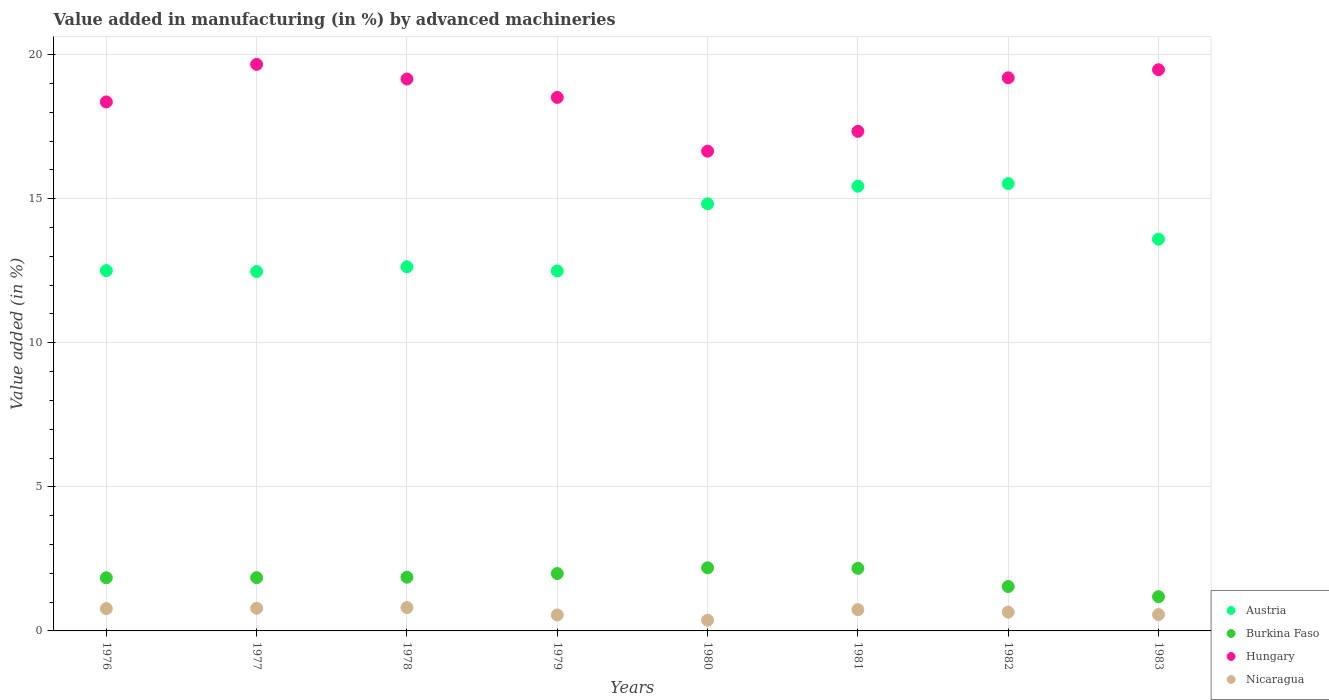How many different coloured dotlines are there?
Offer a very short reply. 4. What is the percentage of value added in manufacturing by advanced machineries in Burkina Faso in 1982?
Make the answer very short. 1.54. Across all years, what is the maximum percentage of value added in manufacturing by advanced machineries in Nicaragua?
Your response must be concise. 0.81. Across all years, what is the minimum percentage of value added in manufacturing by advanced machineries in Austria?
Your response must be concise. 12.47. What is the total percentage of value added in manufacturing by advanced machineries in Austria in the graph?
Ensure brevity in your answer.  109.49. What is the difference between the percentage of value added in manufacturing by advanced machineries in Hungary in 1976 and that in 1979?
Your answer should be compact. -0.16. What is the difference between the percentage of value added in manufacturing by advanced machineries in Nicaragua in 1980 and the percentage of value added in manufacturing by advanced machineries in Austria in 1982?
Keep it short and to the point. -15.16. What is the average percentage of value added in manufacturing by advanced machineries in Hungary per year?
Offer a very short reply. 18.54. In the year 1980, what is the difference between the percentage of value added in manufacturing by advanced machineries in Austria and percentage of value added in manufacturing by advanced machineries in Nicaragua?
Give a very brief answer. 14.45. In how many years, is the percentage of value added in manufacturing by advanced machineries in Austria greater than 4 %?
Offer a terse response. 8. What is the ratio of the percentage of value added in manufacturing by advanced machineries in Austria in 1979 to that in 1982?
Ensure brevity in your answer.  0.8. Is the difference between the percentage of value added in manufacturing by advanced machineries in Austria in 1977 and 1979 greater than the difference between the percentage of value added in manufacturing by advanced machineries in Nicaragua in 1977 and 1979?
Your answer should be very brief. No. What is the difference between the highest and the second highest percentage of value added in manufacturing by advanced machineries in Hungary?
Your response must be concise. 0.19. What is the difference between the highest and the lowest percentage of value added in manufacturing by advanced machineries in Austria?
Offer a very short reply. 3.05. Is the sum of the percentage of value added in manufacturing by advanced machineries in Hungary in 1982 and 1983 greater than the maximum percentage of value added in manufacturing by advanced machineries in Burkina Faso across all years?
Your answer should be very brief. Yes. Does the percentage of value added in manufacturing by advanced machineries in Burkina Faso monotonically increase over the years?
Ensure brevity in your answer.  No. Is the percentage of value added in manufacturing by advanced machineries in Austria strictly greater than the percentage of value added in manufacturing by advanced machineries in Nicaragua over the years?
Your response must be concise. Yes. Is the percentage of value added in manufacturing by advanced machineries in Burkina Faso strictly less than the percentage of value added in manufacturing by advanced machineries in Hungary over the years?
Provide a succinct answer. Yes. What is the difference between two consecutive major ticks on the Y-axis?
Offer a very short reply. 5. Does the graph contain any zero values?
Ensure brevity in your answer.  No. How many legend labels are there?
Your response must be concise. 4. What is the title of the graph?
Make the answer very short. Value added in manufacturing (in %) by advanced machineries. Does "Bermuda" appear as one of the legend labels in the graph?
Offer a very short reply. No. What is the label or title of the Y-axis?
Offer a terse response. Value added (in %). What is the Value added (in %) of Austria in 1976?
Your answer should be compact. 12.5. What is the Value added (in %) of Burkina Faso in 1976?
Offer a very short reply. 1.85. What is the Value added (in %) of Hungary in 1976?
Ensure brevity in your answer.  18.36. What is the Value added (in %) of Nicaragua in 1976?
Your response must be concise. 0.77. What is the Value added (in %) in Austria in 1977?
Provide a succinct answer. 12.47. What is the Value added (in %) in Burkina Faso in 1977?
Give a very brief answer. 1.85. What is the Value added (in %) in Hungary in 1977?
Provide a succinct answer. 19.66. What is the Value added (in %) in Nicaragua in 1977?
Provide a succinct answer. 0.79. What is the Value added (in %) of Austria in 1978?
Your answer should be compact. 12.64. What is the Value added (in %) of Burkina Faso in 1978?
Give a very brief answer. 1.86. What is the Value added (in %) in Hungary in 1978?
Your response must be concise. 19.16. What is the Value added (in %) in Nicaragua in 1978?
Give a very brief answer. 0.81. What is the Value added (in %) of Austria in 1979?
Your answer should be very brief. 12.49. What is the Value added (in %) of Burkina Faso in 1979?
Your response must be concise. 1.99. What is the Value added (in %) of Hungary in 1979?
Offer a very short reply. 18.52. What is the Value added (in %) of Nicaragua in 1979?
Ensure brevity in your answer.  0.55. What is the Value added (in %) of Austria in 1980?
Your response must be concise. 14.82. What is the Value added (in %) in Burkina Faso in 1980?
Ensure brevity in your answer.  2.19. What is the Value added (in %) of Hungary in 1980?
Keep it short and to the point. 16.65. What is the Value added (in %) in Nicaragua in 1980?
Your answer should be compact. 0.37. What is the Value added (in %) of Austria in 1981?
Offer a terse response. 15.43. What is the Value added (in %) in Burkina Faso in 1981?
Your answer should be compact. 2.17. What is the Value added (in %) in Hungary in 1981?
Your response must be concise. 17.34. What is the Value added (in %) of Nicaragua in 1981?
Your answer should be very brief. 0.74. What is the Value added (in %) in Austria in 1982?
Give a very brief answer. 15.53. What is the Value added (in %) in Burkina Faso in 1982?
Keep it short and to the point. 1.54. What is the Value added (in %) in Hungary in 1982?
Provide a short and direct response. 19.2. What is the Value added (in %) of Nicaragua in 1982?
Your response must be concise. 0.65. What is the Value added (in %) in Austria in 1983?
Your response must be concise. 13.6. What is the Value added (in %) in Burkina Faso in 1983?
Keep it short and to the point. 1.19. What is the Value added (in %) in Hungary in 1983?
Give a very brief answer. 19.48. What is the Value added (in %) in Nicaragua in 1983?
Your answer should be very brief. 0.57. Across all years, what is the maximum Value added (in %) in Austria?
Provide a succinct answer. 15.53. Across all years, what is the maximum Value added (in %) in Burkina Faso?
Provide a short and direct response. 2.19. Across all years, what is the maximum Value added (in %) of Hungary?
Ensure brevity in your answer.  19.66. Across all years, what is the maximum Value added (in %) in Nicaragua?
Make the answer very short. 0.81. Across all years, what is the minimum Value added (in %) of Austria?
Make the answer very short. 12.47. Across all years, what is the minimum Value added (in %) in Burkina Faso?
Offer a terse response. 1.19. Across all years, what is the minimum Value added (in %) of Hungary?
Provide a succinct answer. 16.65. Across all years, what is the minimum Value added (in %) of Nicaragua?
Your response must be concise. 0.37. What is the total Value added (in %) of Austria in the graph?
Keep it short and to the point. 109.49. What is the total Value added (in %) of Burkina Faso in the graph?
Offer a terse response. 14.64. What is the total Value added (in %) of Hungary in the graph?
Make the answer very short. 148.36. What is the total Value added (in %) in Nicaragua in the graph?
Keep it short and to the point. 5.26. What is the difference between the Value added (in %) of Austria in 1976 and that in 1977?
Ensure brevity in your answer.  0.03. What is the difference between the Value added (in %) in Burkina Faso in 1976 and that in 1977?
Ensure brevity in your answer.  -0. What is the difference between the Value added (in %) of Hungary in 1976 and that in 1977?
Your answer should be compact. -1.3. What is the difference between the Value added (in %) of Nicaragua in 1976 and that in 1977?
Give a very brief answer. -0.01. What is the difference between the Value added (in %) in Austria in 1976 and that in 1978?
Provide a short and direct response. -0.13. What is the difference between the Value added (in %) in Burkina Faso in 1976 and that in 1978?
Offer a terse response. -0.02. What is the difference between the Value added (in %) of Hungary in 1976 and that in 1978?
Provide a succinct answer. -0.8. What is the difference between the Value added (in %) of Nicaragua in 1976 and that in 1978?
Offer a very short reply. -0.04. What is the difference between the Value added (in %) of Austria in 1976 and that in 1979?
Ensure brevity in your answer.  0.01. What is the difference between the Value added (in %) in Burkina Faso in 1976 and that in 1979?
Keep it short and to the point. -0.15. What is the difference between the Value added (in %) in Hungary in 1976 and that in 1979?
Your answer should be very brief. -0.16. What is the difference between the Value added (in %) of Nicaragua in 1976 and that in 1979?
Keep it short and to the point. 0.22. What is the difference between the Value added (in %) of Austria in 1976 and that in 1980?
Your answer should be compact. -2.32. What is the difference between the Value added (in %) of Burkina Faso in 1976 and that in 1980?
Offer a terse response. -0.35. What is the difference between the Value added (in %) in Hungary in 1976 and that in 1980?
Provide a succinct answer. 1.71. What is the difference between the Value added (in %) of Nicaragua in 1976 and that in 1980?
Offer a terse response. 0.4. What is the difference between the Value added (in %) of Austria in 1976 and that in 1981?
Offer a terse response. -2.93. What is the difference between the Value added (in %) of Burkina Faso in 1976 and that in 1981?
Offer a very short reply. -0.33. What is the difference between the Value added (in %) in Hungary in 1976 and that in 1981?
Your answer should be compact. 1.02. What is the difference between the Value added (in %) in Nicaragua in 1976 and that in 1981?
Your answer should be compact. 0.04. What is the difference between the Value added (in %) in Austria in 1976 and that in 1982?
Your response must be concise. -3.02. What is the difference between the Value added (in %) of Burkina Faso in 1976 and that in 1982?
Provide a short and direct response. 0.3. What is the difference between the Value added (in %) in Hungary in 1976 and that in 1982?
Your answer should be very brief. -0.84. What is the difference between the Value added (in %) in Nicaragua in 1976 and that in 1982?
Provide a short and direct response. 0.12. What is the difference between the Value added (in %) in Austria in 1976 and that in 1983?
Keep it short and to the point. -1.09. What is the difference between the Value added (in %) in Burkina Faso in 1976 and that in 1983?
Give a very brief answer. 0.66. What is the difference between the Value added (in %) in Hungary in 1976 and that in 1983?
Your response must be concise. -1.12. What is the difference between the Value added (in %) of Nicaragua in 1976 and that in 1983?
Offer a very short reply. 0.21. What is the difference between the Value added (in %) of Austria in 1977 and that in 1978?
Offer a very short reply. -0.16. What is the difference between the Value added (in %) in Burkina Faso in 1977 and that in 1978?
Your answer should be very brief. -0.02. What is the difference between the Value added (in %) in Hungary in 1977 and that in 1978?
Your response must be concise. 0.51. What is the difference between the Value added (in %) of Nicaragua in 1977 and that in 1978?
Your answer should be very brief. -0.02. What is the difference between the Value added (in %) in Austria in 1977 and that in 1979?
Give a very brief answer. -0.02. What is the difference between the Value added (in %) in Burkina Faso in 1977 and that in 1979?
Offer a terse response. -0.14. What is the difference between the Value added (in %) in Hungary in 1977 and that in 1979?
Provide a succinct answer. 1.15. What is the difference between the Value added (in %) of Nicaragua in 1977 and that in 1979?
Provide a succinct answer. 0.23. What is the difference between the Value added (in %) of Austria in 1977 and that in 1980?
Ensure brevity in your answer.  -2.35. What is the difference between the Value added (in %) of Burkina Faso in 1977 and that in 1980?
Give a very brief answer. -0.34. What is the difference between the Value added (in %) in Hungary in 1977 and that in 1980?
Provide a succinct answer. 3.01. What is the difference between the Value added (in %) of Nicaragua in 1977 and that in 1980?
Offer a terse response. 0.42. What is the difference between the Value added (in %) in Austria in 1977 and that in 1981?
Offer a very short reply. -2.96. What is the difference between the Value added (in %) in Burkina Faso in 1977 and that in 1981?
Give a very brief answer. -0.32. What is the difference between the Value added (in %) of Hungary in 1977 and that in 1981?
Make the answer very short. 2.32. What is the difference between the Value added (in %) of Nicaragua in 1977 and that in 1981?
Your response must be concise. 0.05. What is the difference between the Value added (in %) in Austria in 1977 and that in 1982?
Give a very brief answer. -3.05. What is the difference between the Value added (in %) of Burkina Faso in 1977 and that in 1982?
Provide a short and direct response. 0.31. What is the difference between the Value added (in %) in Hungary in 1977 and that in 1982?
Your response must be concise. 0.47. What is the difference between the Value added (in %) of Nicaragua in 1977 and that in 1982?
Ensure brevity in your answer.  0.13. What is the difference between the Value added (in %) in Austria in 1977 and that in 1983?
Offer a very short reply. -1.12. What is the difference between the Value added (in %) in Burkina Faso in 1977 and that in 1983?
Give a very brief answer. 0.66. What is the difference between the Value added (in %) of Hungary in 1977 and that in 1983?
Keep it short and to the point. 0.19. What is the difference between the Value added (in %) in Nicaragua in 1977 and that in 1983?
Make the answer very short. 0.22. What is the difference between the Value added (in %) in Austria in 1978 and that in 1979?
Your answer should be very brief. 0.14. What is the difference between the Value added (in %) in Burkina Faso in 1978 and that in 1979?
Your answer should be compact. -0.13. What is the difference between the Value added (in %) in Hungary in 1978 and that in 1979?
Your answer should be very brief. 0.64. What is the difference between the Value added (in %) of Nicaragua in 1978 and that in 1979?
Provide a short and direct response. 0.25. What is the difference between the Value added (in %) in Austria in 1978 and that in 1980?
Provide a succinct answer. -2.19. What is the difference between the Value added (in %) in Burkina Faso in 1978 and that in 1980?
Your answer should be very brief. -0.33. What is the difference between the Value added (in %) in Hungary in 1978 and that in 1980?
Give a very brief answer. 2.5. What is the difference between the Value added (in %) of Nicaragua in 1978 and that in 1980?
Your answer should be very brief. 0.44. What is the difference between the Value added (in %) of Austria in 1978 and that in 1981?
Your response must be concise. -2.8. What is the difference between the Value added (in %) of Burkina Faso in 1978 and that in 1981?
Make the answer very short. -0.31. What is the difference between the Value added (in %) in Hungary in 1978 and that in 1981?
Give a very brief answer. 1.82. What is the difference between the Value added (in %) of Nicaragua in 1978 and that in 1981?
Offer a terse response. 0.07. What is the difference between the Value added (in %) of Austria in 1978 and that in 1982?
Your answer should be very brief. -2.89. What is the difference between the Value added (in %) of Burkina Faso in 1978 and that in 1982?
Make the answer very short. 0.32. What is the difference between the Value added (in %) in Hungary in 1978 and that in 1982?
Your answer should be compact. -0.04. What is the difference between the Value added (in %) of Nicaragua in 1978 and that in 1982?
Offer a terse response. 0.16. What is the difference between the Value added (in %) of Austria in 1978 and that in 1983?
Offer a very short reply. -0.96. What is the difference between the Value added (in %) in Burkina Faso in 1978 and that in 1983?
Ensure brevity in your answer.  0.68. What is the difference between the Value added (in %) in Hungary in 1978 and that in 1983?
Your response must be concise. -0.32. What is the difference between the Value added (in %) in Nicaragua in 1978 and that in 1983?
Your response must be concise. 0.24. What is the difference between the Value added (in %) in Austria in 1979 and that in 1980?
Your answer should be compact. -2.33. What is the difference between the Value added (in %) in Burkina Faso in 1979 and that in 1980?
Provide a short and direct response. -0.2. What is the difference between the Value added (in %) in Hungary in 1979 and that in 1980?
Provide a succinct answer. 1.86. What is the difference between the Value added (in %) of Nicaragua in 1979 and that in 1980?
Your answer should be very brief. 0.18. What is the difference between the Value added (in %) of Austria in 1979 and that in 1981?
Keep it short and to the point. -2.94. What is the difference between the Value added (in %) in Burkina Faso in 1979 and that in 1981?
Provide a succinct answer. -0.18. What is the difference between the Value added (in %) of Hungary in 1979 and that in 1981?
Make the answer very short. 1.18. What is the difference between the Value added (in %) of Nicaragua in 1979 and that in 1981?
Your answer should be very brief. -0.18. What is the difference between the Value added (in %) in Austria in 1979 and that in 1982?
Provide a succinct answer. -3.03. What is the difference between the Value added (in %) in Burkina Faso in 1979 and that in 1982?
Give a very brief answer. 0.45. What is the difference between the Value added (in %) in Hungary in 1979 and that in 1982?
Give a very brief answer. -0.68. What is the difference between the Value added (in %) of Nicaragua in 1979 and that in 1982?
Your response must be concise. -0.1. What is the difference between the Value added (in %) in Austria in 1979 and that in 1983?
Make the answer very short. -1.1. What is the difference between the Value added (in %) in Burkina Faso in 1979 and that in 1983?
Offer a very short reply. 0.8. What is the difference between the Value added (in %) of Hungary in 1979 and that in 1983?
Keep it short and to the point. -0.96. What is the difference between the Value added (in %) of Nicaragua in 1979 and that in 1983?
Give a very brief answer. -0.01. What is the difference between the Value added (in %) of Austria in 1980 and that in 1981?
Make the answer very short. -0.61. What is the difference between the Value added (in %) in Burkina Faso in 1980 and that in 1981?
Your answer should be very brief. 0.02. What is the difference between the Value added (in %) of Hungary in 1980 and that in 1981?
Ensure brevity in your answer.  -0.69. What is the difference between the Value added (in %) in Nicaragua in 1980 and that in 1981?
Your response must be concise. -0.37. What is the difference between the Value added (in %) of Austria in 1980 and that in 1982?
Provide a succinct answer. -0.7. What is the difference between the Value added (in %) in Burkina Faso in 1980 and that in 1982?
Make the answer very short. 0.65. What is the difference between the Value added (in %) of Hungary in 1980 and that in 1982?
Your response must be concise. -2.55. What is the difference between the Value added (in %) in Nicaragua in 1980 and that in 1982?
Give a very brief answer. -0.28. What is the difference between the Value added (in %) of Austria in 1980 and that in 1983?
Your answer should be very brief. 1.23. What is the difference between the Value added (in %) of Hungary in 1980 and that in 1983?
Your answer should be very brief. -2.83. What is the difference between the Value added (in %) in Nicaragua in 1980 and that in 1983?
Provide a succinct answer. -0.2. What is the difference between the Value added (in %) of Austria in 1981 and that in 1982?
Your answer should be very brief. -0.09. What is the difference between the Value added (in %) in Burkina Faso in 1981 and that in 1982?
Your answer should be compact. 0.63. What is the difference between the Value added (in %) of Hungary in 1981 and that in 1982?
Make the answer very short. -1.86. What is the difference between the Value added (in %) in Nicaragua in 1981 and that in 1982?
Keep it short and to the point. 0.09. What is the difference between the Value added (in %) in Austria in 1981 and that in 1983?
Provide a succinct answer. 1.84. What is the difference between the Value added (in %) of Burkina Faso in 1981 and that in 1983?
Give a very brief answer. 0.98. What is the difference between the Value added (in %) in Hungary in 1981 and that in 1983?
Offer a terse response. -2.14. What is the difference between the Value added (in %) of Nicaragua in 1981 and that in 1983?
Offer a terse response. 0.17. What is the difference between the Value added (in %) of Austria in 1982 and that in 1983?
Offer a terse response. 1.93. What is the difference between the Value added (in %) in Burkina Faso in 1982 and that in 1983?
Give a very brief answer. 0.35. What is the difference between the Value added (in %) of Hungary in 1982 and that in 1983?
Keep it short and to the point. -0.28. What is the difference between the Value added (in %) in Nicaragua in 1982 and that in 1983?
Offer a terse response. 0.08. What is the difference between the Value added (in %) of Austria in 1976 and the Value added (in %) of Burkina Faso in 1977?
Your response must be concise. 10.66. What is the difference between the Value added (in %) in Austria in 1976 and the Value added (in %) in Hungary in 1977?
Offer a very short reply. -7.16. What is the difference between the Value added (in %) in Austria in 1976 and the Value added (in %) in Nicaragua in 1977?
Offer a terse response. 11.72. What is the difference between the Value added (in %) in Burkina Faso in 1976 and the Value added (in %) in Hungary in 1977?
Offer a terse response. -17.82. What is the difference between the Value added (in %) of Burkina Faso in 1976 and the Value added (in %) of Nicaragua in 1977?
Offer a very short reply. 1.06. What is the difference between the Value added (in %) of Hungary in 1976 and the Value added (in %) of Nicaragua in 1977?
Your response must be concise. 17.57. What is the difference between the Value added (in %) in Austria in 1976 and the Value added (in %) in Burkina Faso in 1978?
Provide a succinct answer. 10.64. What is the difference between the Value added (in %) of Austria in 1976 and the Value added (in %) of Hungary in 1978?
Provide a succinct answer. -6.65. What is the difference between the Value added (in %) in Austria in 1976 and the Value added (in %) in Nicaragua in 1978?
Your answer should be very brief. 11.69. What is the difference between the Value added (in %) of Burkina Faso in 1976 and the Value added (in %) of Hungary in 1978?
Offer a terse response. -17.31. What is the difference between the Value added (in %) of Burkina Faso in 1976 and the Value added (in %) of Nicaragua in 1978?
Give a very brief answer. 1.04. What is the difference between the Value added (in %) in Hungary in 1976 and the Value added (in %) in Nicaragua in 1978?
Give a very brief answer. 17.55. What is the difference between the Value added (in %) of Austria in 1976 and the Value added (in %) of Burkina Faso in 1979?
Keep it short and to the point. 10.51. What is the difference between the Value added (in %) in Austria in 1976 and the Value added (in %) in Hungary in 1979?
Ensure brevity in your answer.  -6.01. What is the difference between the Value added (in %) of Austria in 1976 and the Value added (in %) of Nicaragua in 1979?
Your answer should be very brief. 11.95. What is the difference between the Value added (in %) in Burkina Faso in 1976 and the Value added (in %) in Hungary in 1979?
Keep it short and to the point. -16.67. What is the difference between the Value added (in %) of Burkina Faso in 1976 and the Value added (in %) of Nicaragua in 1979?
Your answer should be very brief. 1.29. What is the difference between the Value added (in %) in Hungary in 1976 and the Value added (in %) in Nicaragua in 1979?
Keep it short and to the point. 17.81. What is the difference between the Value added (in %) in Austria in 1976 and the Value added (in %) in Burkina Faso in 1980?
Ensure brevity in your answer.  10.31. What is the difference between the Value added (in %) in Austria in 1976 and the Value added (in %) in Hungary in 1980?
Make the answer very short. -4.15. What is the difference between the Value added (in %) in Austria in 1976 and the Value added (in %) in Nicaragua in 1980?
Make the answer very short. 12.13. What is the difference between the Value added (in %) of Burkina Faso in 1976 and the Value added (in %) of Hungary in 1980?
Provide a short and direct response. -14.81. What is the difference between the Value added (in %) in Burkina Faso in 1976 and the Value added (in %) in Nicaragua in 1980?
Keep it short and to the point. 1.47. What is the difference between the Value added (in %) in Hungary in 1976 and the Value added (in %) in Nicaragua in 1980?
Provide a short and direct response. 17.99. What is the difference between the Value added (in %) of Austria in 1976 and the Value added (in %) of Burkina Faso in 1981?
Make the answer very short. 10.33. What is the difference between the Value added (in %) in Austria in 1976 and the Value added (in %) in Hungary in 1981?
Your answer should be compact. -4.83. What is the difference between the Value added (in %) of Austria in 1976 and the Value added (in %) of Nicaragua in 1981?
Give a very brief answer. 11.76. What is the difference between the Value added (in %) in Burkina Faso in 1976 and the Value added (in %) in Hungary in 1981?
Offer a very short reply. -15.49. What is the difference between the Value added (in %) of Burkina Faso in 1976 and the Value added (in %) of Nicaragua in 1981?
Your answer should be very brief. 1.11. What is the difference between the Value added (in %) in Hungary in 1976 and the Value added (in %) in Nicaragua in 1981?
Ensure brevity in your answer.  17.62. What is the difference between the Value added (in %) of Austria in 1976 and the Value added (in %) of Burkina Faso in 1982?
Your answer should be very brief. 10.96. What is the difference between the Value added (in %) in Austria in 1976 and the Value added (in %) in Hungary in 1982?
Offer a terse response. -6.69. What is the difference between the Value added (in %) in Austria in 1976 and the Value added (in %) in Nicaragua in 1982?
Your response must be concise. 11.85. What is the difference between the Value added (in %) of Burkina Faso in 1976 and the Value added (in %) of Hungary in 1982?
Your response must be concise. -17.35. What is the difference between the Value added (in %) in Burkina Faso in 1976 and the Value added (in %) in Nicaragua in 1982?
Your answer should be compact. 1.19. What is the difference between the Value added (in %) of Hungary in 1976 and the Value added (in %) of Nicaragua in 1982?
Offer a very short reply. 17.71. What is the difference between the Value added (in %) in Austria in 1976 and the Value added (in %) in Burkina Faso in 1983?
Ensure brevity in your answer.  11.32. What is the difference between the Value added (in %) of Austria in 1976 and the Value added (in %) of Hungary in 1983?
Your response must be concise. -6.97. What is the difference between the Value added (in %) in Austria in 1976 and the Value added (in %) in Nicaragua in 1983?
Give a very brief answer. 11.94. What is the difference between the Value added (in %) in Burkina Faso in 1976 and the Value added (in %) in Hungary in 1983?
Offer a terse response. -17.63. What is the difference between the Value added (in %) in Burkina Faso in 1976 and the Value added (in %) in Nicaragua in 1983?
Ensure brevity in your answer.  1.28. What is the difference between the Value added (in %) of Hungary in 1976 and the Value added (in %) of Nicaragua in 1983?
Your response must be concise. 17.79. What is the difference between the Value added (in %) in Austria in 1977 and the Value added (in %) in Burkina Faso in 1978?
Offer a very short reply. 10.61. What is the difference between the Value added (in %) in Austria in 1977 and the Value added (in %) in Hungary in 1978?
Make the answer very short. -6.68. What is the difference between the Value added (in %) of Austria in 1977 and the Value added (in %) of Nicaragua in 1978?
Provide a succinct answer. 11.66. What is the difference between the Value added (in %) of Burkina Faso in 1977 and the Value added (in %) of Hungary in 1978?
Your response must be concise. -17.31. What is the difference between the Value added (in %) in Burkina Faso in 1977 and the Value added (in %) in Nicaragua in 1978?
Give a very brief answer. 1.04. What is the difference between the Value added (in %) in Hungary in 1977 and the Value added (in %) in Nicaragua in 1978?
Your response must be concise. 18.85. What is the difference between the Value added (in %) of Austria in 1977 and the Value added (in %) of Burkina Faso in 1979?
Offer a terse response. 10.48. What is the difference between the Value added (in %) in Austria in 1977 and the Value added (in %) in Hungary in 1979?
Your answer should be very brief. -6.04. What is the difference between the Value added (in %) of Austria in 1977 and the Value added (in %) of Nicaragua in 1979?
Your answer should be compact. 11.92. What is the difference between the Value added (in %) of Burkina Faso in 1977 and the Value added (in %) of Hungary in 1979?
Offer a terse response. -16.67. What is the difference between the Value added (in %) in Burkina Faso in 1977 and the Value added (in %) in Nicaragua in 1979?
Make the answer very short. 1.29. What is the difference between the Value added (in %) of Hungary in 1977 and the Value added (in %) of Nicaragua in 1979?
Your answer should be very brief. 19.11. What is the difference between the Value added (in %) in Austria in 1977 and the Value added (in %) in Burkina Faso in 1980?
Offer a terse response. 10.28. What is the difference between the Value added (in %) in Austria in 1977 and the Value added (in %) in Hungary in 1980?
Your response must be concise. -4.18. What is the difference between the Value added (in %) of Austria in 1977 and the Value added (in %) of Nicaragua in 1980?
Offer a very short reply. 12.1. What is the difference between the Value added (in %) of Burkina Faso in 1977 and the Value added (in %) of Hungary in 1980?
Your answer should be compact. -14.8. What is the difference between the Value added (in %) of Burkina Faso in 1977 and the Value added (in %) of Nicaragua in 1980?
Provide a short and direct response. 1.48. What is the difference between the Value added (in %) in Hungary in 1977 and the Value added (in %) in Nicaragua in 1980?
Offer a terse response. 19.29. What is the difference between the Value added (in %) of Austria in 1977 and the Value added (in %) of Burkina Faso in 1981?
Give a very brief answer. 10.3. What is the difference between the Value added (in %) of Austria in 1977 and the Value added (in %) of Hungary in 1981?
Your answer should be compact. -4.86. What is the difference between the Value added (in %) of Austria in 1977 and the Value added (in %) of Nicaragua in 1981?
Give a very brief answer. 11.73. What is the difference between the Value added (in %) of Burkina Faso in 1977 and the Value added (in %) of Hungary in 1981?
Your response must be concise. -15.49. What is the difference between the Value added (in %) in Burkina Faso in 1977 and the Value added (in %) in Nicaragua in 1981?
Provide a succinct answer. 1.11. What is the difference between the Value added (in %) of Hungary in 1977 and the Value added (in %) of Nicaragua in 1981?
Make the answer very short. 18.92. What is the difference between the Value added (in %) of Austria in 1977 and the Value added (in %) of Burkina Faso in 1982?
Make the answer very short. 10.93. What is the difference between the Value added (in %) in Austria in 1977 and the Value added (in %) in Hungary in 1982?
Your answer should be compact. -6.72. What is the difference between the Value added (in %) of Austria in 1977 and the Value added (in %) of Nicaragua in 1982?
Offer a terse response. 11.82. What is the difference between the Value added (in %) in Burkina Faso in 1977 and the Value added (in %) in Hungary in 1982?
Your response must be concise. -17.35. What is the difference between the Value added (in %) in Burkina Faso in 1977 and the Value added (in %) in Nicaragua in 1982?
Provide a succinct answer. 1.2. What is the difference between the Value added (in %) of Hungary in 1977 and the Value added (in %) of Nicaragua in 1982?
Your answer should be very brief. 19.01. What is the difference between the Value added (in %) of Austria in 1977 and the Value added (in %) of Burkina Faso in 1983?
Provide a succinct answer. 11.29. What is the difference between the Value added (in %) in Austria in 1977 and the Value added (in %) in Hungary in 1983?
Your response must be concise. -7. What is the difference between the Value added (in %) of Austria in 1977 and the Value added (in %) of Nicaragua in 1983?
Your answer should be very brief. 11.91. What is the difference between the Value added (in %) in Burkina Faso in 1977 and the Value added (in %) in Hungary in 1983?
Your answer should be compact. -17.63. What is the difference between the Value added (in %) in Burkina Faso in 1977 and the Value added (in %) in Nicaragua in 1983?
Offer a terse response. 1.28. What is the difference between the Value added (in %) of Hungary in 1977 and the Value added (in %) of Nicaragua in 1983?
Make the answer very short. 19.1. What is the difference between the Value added (in %) in Austria in 1978 and the Value added (in %) in Burkina Faso in 1979?
Provide a succinct answer. 10.65. What is the difference between the Value added (in %) of Austria in 1978 and the Value added (in %) of Hungary in 1979?
Give a very brief answer. -5.88. What is the difference between the Value added (in %) of Austria in 1978 and the Value added (in %) of Nicaragua in 1979?
Make the answer very short. 12.08. What is the difference between the Value added (in %) in Burkina Faso in 1978 and the Value added (in %) in Hungary in 1979?
Your answer should be compact. -16.65. What is the difference between the Value added (in %) in Burkina Faso in 1978 and the Value added (in %) in Nicaragua in 1979?
Give a very brief answer. 1.31. What is the difference between the Value added (in %) of Hungary in 1978 and the Value added (in %) of Nicaragua in 1979?
Provide a short and direct response. 18.6. What is the difference between the Value added (in %) in Austria in 1978 and the Value added (in %) in Burkina Faso in 1980?
Offer a terse response. 10.45. What is the difference between the Value added (in %) of Austria in 1978 and the Value added (in %) of Hungary in 1980?
Provide a succinct answer. -4.01. What is the difference between the Value added (in %) of Austria in 1978 and the Value added (in %) of Nicaragua in 1980?
Give a very brief answer. 12.27. What is the difference between the Value added (in %) of Burkina Faso in 1978 and the Value added (in %) of Hungary in 1980?
Provide a succinct answer. -14.79. What is the difference between the Value added (in %) in Burkina Faso in 1978 and the Value added (in %) in Nicaragua in 1980?
Offer a terse response. 1.49. What is the difference between the Value added (in %) in Hungary in 1978 and the Value added (in %) in Nicaragua in 1980?
Offer a very short reply. 18.78. What is the difference between the Value added (in %) in Austria in 1978 and the Value added (in %) in Burkina Faso in 1981?
Your answer should be very brief. 10.46. What is the difference between the Value added (in %) of Austria in 1978 and the Value added (in %) of Hungary in 1981?
Your answer should be very brief. -4.7. What is the difference between the Value added (in %) in Austria in 1978 and the Value added (in %) in Nicaragua in 1981?
Offer a very short reply. 11.9. What is the difference between the Value added (in %) in Burkina Faso in 1978 and the Value added (in %) in Hungary in 1981?
Your answer should be very brief. -15.48. What is the difference between the Value added (in %) of Burkina Faso in 1978 and the Value added (in %) of Nicaragua in 1981?
Keep it short and to the point. 1.12. What is the difference between the Value added (in %) of Hungary in 1978 and the Value added (in %) of Nicaragua in 1981?
Keep it short and to the point. 18.42. What is the difference between the Value added (in %) of Austria in 1978 and the Value added (in %) of Burkina Faso in 1982?
Provide a succinct answer. 11.1. What is the difference between the Value added (in %) in Austria in 1978 and the Value added (in %) in Hungary in 1982?
Offer a very short reply. -6.56. What is the difference between the Value added (in %) in Austria in 1978 and the Value added (in %) in Nicaragua in 1982?
Provide a succinct answer. 11.98. What is the difference between the Value added (in %) of Burkina Faso in 1978 and the Value added (in %) of Hungary in 1982?
Keep it short and to the point. -17.33. What is the difference between the Value added (in %) of Burkina Faso in 1978 and the Value added (in %) of Nicaragua in 1982?
Your response must be concise. 1.21. What is the difference between the Value added (in %) in Hungary in 1978 and the Value added (in %) in Nicaragua in 1982?
Give a very brief answer. 18.5. What is the difference between the Value added (in %) of Austria in 1978 and the Value added (in %) of Burkina Faso in 1983?
Offer a very short reply. 11.45. What is the difference between the Value added (in %) in Austria in 1978 and the Value added (in %) in Hungary in 1983?
Offer a terse response. -6.84. What is the difference between the Value added (in %) of Austria in 1978 and the Value added (in %) of Nicaragua in 1983?
Offer a terse response. 12.07. What is the difference between the Value added (in %) in Burkina Faso in 1978 and the Value added (in %) in Hungary in 1983?
Your answer should be very brief. -17.61. What is the difference between the Value added (in %) of Burkina Faso in 1978 and the Value added (in %) of Nicaragua in 1983?
Keep it short and to the point. 1.3. What is the difference between the Value added (in %) in Hungary in 1978 and the Value added (in %) in Nicaragua in 1983?
Keep it short and to the point. 18.59. What is the difference between the Value added (in %) of Austria in 1979 and the Value added (in %) of Burkina Faso in 1980?
Your answer should be very brief. 10.3. What is the difference between the Value added (in %) in Austria in 1979 and the Value added (in %) in Hungary in 1980?
Your answer should be very brief. -4.16. What is the difference between the Value added (in %) in Austria in 1979 and the Value added (in %) in Nicaragua in 1980?
Give a very brief answer. 12.12. What is the difference between the Value added (in %) in Burkina Faso in 1979 and the Value added (in %) in Hungary in 1980?
Provide a short and direct response. -14.66. What is the difference between the Value added (in %) of Burkina Faso in 1979 and the Value added (in %) of Nicaragua in 1980?
Keep it short and to the point. 1.62. What is the difference between the Value added (in %) in Hungary in 1979 and the Value added (in %) in Nicaragua in 1980?
Provide a short and direct response. 18.15. What is the difference between the Value added (in %) in Austria in 1979 and the Value added (in %) in Burkina Faso in 1981?
Ensure brevity in your answer.  10.32. What is the difference between the Value added (in %) of Austria in 1979 and the Value added (in %) of Hungary in 1981?
Your answer should be very brief. -4.85. What is the difference between the Value added (in %) of Austria in 1979 and the Value added (in %) of Nicaragua in 1981?
Your answer should be very brief. 11.75. What is the difference between the Value added (in %) of Burkina Faso in 1979 and the Value added (in %) of Hungary in 1981?
Your answer should be compact. -15.35. What is the difference between the Value added (in %) of Burkina Faso in 1979 and the Value added (in %) of Nicaragua in 1981?
Provide a short and direct response. 1.25. What is the difference between the Value added (in %) of Hungary in 1979 and the Value added (in %) of Nicaragua in 1981?
Give a very brief answer. 17.78. What is the difference between the Value added (in %) in Austria in 1979 and the Value added (in %) in Burkina Faso in 1982?
Provide a succinct answer. 10.95. What is the difference between the Value added (in %) of Austria in 1979 and the Value added (in %) of Hungary in 1982?
Your answer should be compact. -6.71. What is the difference between the Value added (in %) in Austria in 1979 and the Value added (in %) in Nicaragua in 1982?
Offer a terse response. 11.84. What is the difference between the Value added (in %) of Burkina Faso in 1979 and the Value added (in %) of Hungary in 1982?
Keep it short and to the point. -17.21. What is the difference between the Value added (in %) of Burkina Faso in 1979 and the Value added (in %) of Nicaragua in 1982?
Give a very brief answer. 1.34. What is the difference between the Value added (in %) in Hungary in 1979 and the Value added (in %) in Nicaragua in 1982?
Ensure brevity in your answer.  17.86. What is the difference between the Value added (in %) of Austria in 1979 and the Value added (in %) of Burkina Faso in 1983?
Your answer should be very brief. 11.3. What is the difference between the Value added (in %) of Austria in 1979 and the Value added (in %) of Hungary in 1983?
Offer a terse response. -6.98. What is the difference between the Value added (in %) in Austria in 1979 and the Value added (in %) in Nicaragua in 1983?
Provide a short and direct response. 11.93. What is the difference between the Value added (in %) of Burkina Faso in 1979 and the Value added (in %) of Hungary in 1983?
Your answer should be very brief. -17.49. What is the difference between the Value added (in %) of Burkina Faso in 1979 and the Value added (in %) of Nicaragua in 1983?
Offer a terse response. 1.42. What is the difference between the Value added (in %) of Hungary in 1979 and the Value added (in %) of Nicaragua in 1983?
Offer a very short reply. 17.95. What is the difference between the Value added (in %) of Austria in 1980 and the Value added (in %) of Burkina Faso in 1981?
Your response must be concise. 12.65. What is the difference between the Value added (in %) in Austria in 1980 and the Value added (in %) in Hungary in 1981?
Provide a succinct answer. -2.51. What is the difference between the Value added (in %) of Austria in 1980 and the Value added (in %) of Nicaragua in 1981?
Provide a succinct answer. 14.09. What is the difference between the Value added (in %) of Burkina Faso in 1980 and the Value added (in %) of Hungary in 1981?
Make the answer very short. -15.15. What is the difference between the Value added (in %) in Burkina Faso in 1980 and the Value added (in %) in Nicaragua in 1981?
Keep it short and to the point. 1.45. What is the difference between the Value added (in %) of Hungary in 1980 and the Value added (in %) of Nicaragua in 1981?
Offer a terse response. 15.91. What is the difference between the Value added (in %) of Austria in 1980 and the Value added (in %) of Burkina Faso in 1982?
Offer a terse response. 13.28. What is the difference between the Value added (in %) in Austria in 1980 and the Value added (in %) in Hungary in 1982?
Keep it short and to the point. -4.37. What is the difference between the Value added (in %) in Austria in 1980 and the Value added (in %) in Nicaragua in 1982?
Keep it short and to the point. 14.17. What is the difference between the Value added (in %) in Burkina Faso in 1980 and the Value added (in %) in Hungary in 1982?
Ensure brevity in your answer.  -17.01. What is the difference between the Value added (in %) of Burkina Faso in 1980 and the Value added (in %) of Nicaragua in 1982?
Offer a very short reply. 1.54. What is the difference between the Value added (in %) in Hungary in 1980 and the Value added (in %) in Nicaragua in 1982?
Keep it short and to the point. 16. What is the difference between the Value added (in %) in Austria in 1980 and the Value added (in %) in Burkina Faso in 1983?
Your response must be concise. 13.64. What is the difference between the Value added (in %) of Austria in 1980 and the Value added (in %) of Hungary in 1983?
Provide a succinct answer. -4.65. What is the difference between the Value added (in %) of Austria in 1980 and the Value added (in %) of Nicaragua in 1983?
Your answer should be compact. 14.26. What is the difference between the Value added (in %) in Burkina Faso in 1980 and the Value added (in %) in Hungary in 1983?
Your response must be concise. -17.29. What is the difference between the Value added (in %) in Burkina Faso in 1980 and the Value added (in %) in Nicaragua in 1983?
Your answer should be compact. 1.62. What is the difference between the Value added (in %) of Hungary in 1980 and the Value added (in %) of Nicaragua in 1983?
Make the answer very short. 16.08. What is the difference between the Value added (in %) of Austria in 1981 and the Value added (in %) of Burkina Faso in 1982?
Make the answer very short. 13.89. What is the difference between the Value added (in %) in Austria in 1981 and the Value added (in %) in Hungary in 1982?
Make the answer very short. -3.76. What is the difference between the Value added (in %) in Austria in 1981 and the Value added (in %) in Nicaragua in 1982?
Your answer should be compact. 14.78. What is the difference between the Value added (in %) in Burkina Faso in 1981 and the Value added (in %) in Hungary in 1982?
Give a very brief answer. -17.03. What is the difference between the Value added (in %) of Burkina Faso in 1981 and the Value added (in %) of Nicaragua in 1982?
Keep it short and to the point. 1.52. What is the difference between the Value added (in %) in Hungary in 1981 and the Value added (in %) in Nicaragua in 1982?
Your answer should be compact. 16.69. What is the difference between the Value added (in %) in Austria in 1981 and the Value added (in %) in Burkina Faso in 1983?
Provide a succinct answer. 14.25. What is the difference between the Value added (in %) of Austria in 1981 and the Value added (in %) of Hungary in 1983?
Make the answer very short. -4.04. What is the difference between the Value added (in %) in Austria in 1981 and the Value added (in %) in Nicaragua in 1983?
Provide a short and direct response. 14.87. What is the difference between the Value added (in %) of Burkina Faso in 1981 and the Value added (in %) of Hungary in 1983?
Give a very brief answer. -17.31. What is the difference between the Value added (in %) in Burkina Faso in 1981 and the Value added (in %) in Nicaragua in 1983?
Provide a short and direct response. 1.6. What is the difference between the Value added (in %) of Hungary in 1981 and the Value added (in %) of Nicaragua in 1983?
Keep it short and to the point. 16.77. What is the difference between the Value added (in %) in Austria in 1982 and the Value added (in %) in Burkina Faso in 1983?
Provide a short and direct response. 14.34. What is the difference between the Value added (in %) of Austria in 1982 and the Value added (in %) of Hungary in 1983?
Your answer should be compact. -3.95. What is the difference between the Value added (in %) in Austria in 1982 and the Value added (in %) in Nicaragua in 1983?
Your response must be concise. 14.96. What is the difference between the Value added (in %) in Burkina Faso in 1982 and the Value added (in %) in Hungary in 1983?
Make the answer very short. -17.94. What is the difference between the Value added (in %) in Burkina Faso in 1982 and the Value added (in %) in Nicaragua in 1983?
Offer a very short reply. 0.97. What is the difference between the Value added (in %) of Hungary in 1982 and the Value added (in %) of Nicaragua in 1983?
Ensure brevity in your answer.  18.63. What is the average Value added (in %) in Austria per year?
Your response must be concise. 13.69. What is the average Value added (in %) of Burkina Faso per year?
Your response must be concise. 1.83. What is the average Value added (in %) in Hungary per year?
Provide a short and direct response. 18.55. What is the average Value added (in %) of Nicaragua per year?
Your answer should be compact. 0.66. In the year 1976, what is the difference between the Value added (in %) of Austria and Value added (in %) of Burkina Faso?
Your response must be concise. 10.66. In the year 1976, what is the difference between the Value added (in %) in Austria and Value added (in %) in Hungary?
Provide a succinct answer. -5.86. In the year 1976, what is the difference between the Value added (in %) of Austria and Value added (in %) of Nicaragua?
Provide a short and direct response. 11.73. In the year 1976, what is the difference between the Value added (in %) of Burkina Faso and Value added (in %) of Hungary?
Your answer should be very brief. -16.51. In the year 1976, what is the difference between the Value added (in %) in Burkina Faso and Value added (in %) in Nicaragua?
Your answer should be compact. 1.07. In the year 1976, what is the difference between the Value added (in %) of Hungary and Value added (in %) of Nicaragua?
Provide a succinct answer. 17.59. In the year 1977, what is the difference between the Value added (in %) of Austria and Value added (in %) of Burkina Faso?
Keep it short and to the point. 10.63. In the year 1977, what is the difference between the Value added (in %) of Austria and Value added (in %) of Hungary?
Make the answer very short. -7.19. In the year 1977, what is the difference between the Value added (in %) in Austria and Value added (in %) in Nicaragua?
Offer a very short reply. 11.69. In the year 1977, what is the difference between the Value added (in %) in Burkina Faso and Value added (in %) in Hungary?
Provide a succinct answer. -17.82. In the year 1977, what is the difference between the Value added (in %) of Burkina Faso and Value added (in %) of Nicaragua?
Offer a terse response. 1.06. In the year 1977, what is the difference between the Value added (in %) in Hungary and Value added (in %) in Nicaragua?
Your response must be concise. 18.88. In the year 1978, what is the difference between the Value added (in %) in Austria and Value added (in %) in Burkina Faso?
Make the answer very short. 10.77. In the year 1978, what is the difference between the Value added (in %) of Austria and Value added (in %) of Hungary?
Your answer should be compact. -6.52. In the year 1978, what is the difference between the Value added (in %) of Austria and Value added (in %) of Nicaragua?
Provide a succinct answer. 11.83. In the year 1978, what is the difference between the Value added (in %) of Burkina Faso and Value added (in %) of Hungary?
Make the answer very short. -17.29. In the year 1978, what is the difference between the Value added (in %) in Burkina Faso and Value added (in %) in Nicaragua?
Give a very brief answer. 1.05. In the year 1978, what is the difference between the Value added (in %) of Hungary and Value added (in %) of Nicaragua?
Your answer should be very brief. 18.35. In the year 1979, what is the difference between the Value added (in %) in Austria and Value added (in %) in Burkina Faso?
Offer a very short reply. 10.5. In the year 1979, what is the difference between the Value added (in %) of Austria and Value added (in %) of Hungary?
Your response must be concise. -6.02. In the year 1979, what is the difference between the Value added (in %) in Austria and Value added (in %) in Nicaragua?
Make the answer very short. 11.94. In the year 1979, what is the difference between the Value added (in %) in Burkina Faso and Value added (in %) in Hungary?
Your response must be concise. -16.52. In the year 1979, what is the difference between the Value added (in %) in Burkina Faso and Value added (in %) in Nicaragua?
Provide a short and direct response. 1.44. In the year 1979, what is the difference between the Value added (in %) in Hungary and Value added (in %) in Nicaragua?
Your answer should be very brief. 17.96. In the year 1980, what is the difference between the Value added (in %) of Austria and Value added (in %) of Burkina Faso?
Make the answer very short. 12.63. In the year 1980, what is the difference between the Value added (in %) in Austria and Value added (in %) in Hungary?
Provide a succinct answer. -1.83. In the year 1980, what is the difference between the Value added (in %) in Austria and Value added (in %) in Nicaragua?
Ensure brevity in your answer.  14.45. In the year 1980, what is the difference between the Value added (in %) in Burkina Faso and Value added (in %) in Hungary?
Provide a succinct answer. -14.46. In the year 1980, what is the difference between the Value added (in %) of Burkina Faso and Value added (in %) of Nicaragua?
Make the answer very short. 1.82. In the year 1980, what is the difference between the Value added (in %) in Hungary and Value added (in %) in Nicaragua?
Make the answer very short. 16.28. In the year 1981, what is the difference between the Value added (in %) in Austria and Value added (in %) in Burkina Faso?
Provide a short and direct response. 13.26. In the year 1981, what is the difference between the Value added (in %) of Austria and Value added (in %) of Hungary?
Give a very brief answer. -1.9. In the year 1981, what is the difference between the Value added (in %) of Austria and Value added (in %) of Nicaragua?
Give a very brief answer. 14.7. In the year 1981, what is the difference between the Value added (in %) in Burkina Faso and Value added (in %) in Hungary?
Provide a short and direct response. -15.17. In the year 1981, what is the difference between the Value added (in %) of Burkina Faso and Value added (in %) of Nicaragua?
Offer a terse response. 1.43. In the year 1981, what is the difference between the Value added (in %) in Hungary and Value added (in %) in Nicaragua?
Keep it short and to the point. 16.6. In the year 1982, what is the difference between the Value added (in %) in Austria and Value added (in %) in Burkina Faso?
Give a very brief answer. 13.98. In the year 1982, what is the difference between the Value added (in %) of Austria and Value added (in %) of Hungary?
Offer a terse response. -3.67. In the year 1982, what is the difference between the Value added (in %) in Austria and Value added (in %) in Nicaragua?
Make the answer very short. 14.87. In the year 1982, what is the difference between the Value added (in %) of Burkina Faso and Value added (in %) of Hungary?
Give a very brief answer. -17.66. In the year 1982, what is the difference between the Value added (in %) of Burkina Faso and Value added (in %) of Nicaragua?
Offer a very short reply. 0.89. In the year 1982, what is the difference between the Value added (in %) in Hungary and Value added (in %) in Nicaragua?
Give a very brief answer. 18.55. In the year 1983, what is the difference between the Value added (in %) of Austria and Value added (in %) of Burkina Faso?
Offer a terse response. 12.41. In the year 1983, what is the difference between the Value added (in %) in Austria and Value added (in %) in Hungary?
Your answer should be compact. -5.88. In the year 1983, what is the difference between the Value added (in %) in Austria and Value added (in %) in Nicaragua?
Offer a very short reply. 13.03. In the year 1983, what is the difference between the Value added (in %) in Burkina Faso and Value added (in %) in Hungary?
Provide a succinct answer. -18.29. In the year 1983, what is the difference between the Value added (in %) of Burkina Faso and Value added (in %) of Nicaragua?
Keep it short and to the point. 0.62. In the year 1983, what is the difference between the Value added (in %) of Hungary and Value added (in %) of Nicaragua?
Your answer should be compact. 18.91. What is the ratio of the Value added (in %) in Austria in 1976 to that in 1977?
Provide a short and direct response. 1. What is the ratio of the Value added (in %) of Burkina Faso in 1976 to that in 1977?
Keep it short and to the point. 1. What is the ratio of the Value added (in %) of Hungary in 1976 to that in 1977?
Your answer should be compact. 0.93. What is the ratio of the Value added (in %) in Nicaragua in 1976 to that in 1977?
Your answer should be very brief. 0.98. What is the ratio of the Value added (in %) in Austria in 1976 to that in 1978?
Your response must be concise. 0.99. What is the ratio of the Value added (in %) in Burkina Faso in 1976 to that in 1978?
Your response must be concise. 0.99. What is the ratio of the Value added (in %) of Hungary in 1976 to that in 1978?
Offer a very short reply. 0.96. What is the ratio of the Value added (in %) of Nicaragua in 1976 to that in 1978?
Offer a terse response. 0.96. What is the ratio of the Value added (in %) in Burkina Faso in 1976 to that in 1979?
Your answer should be compact. 0.93. What is the ratio of the Value added (in %) in Nicaragua in 1976 to that in 1979?
Offer a terse response. 1.4. What is the ratio of the Value added (in %) in Austria in 1976 to that in 1980?
Give a very brief answer. 0.84. What is the ratio of the Value added (in %) of Burkina Faso in 1976 to that in 1980?
Provide a short and direct response. 0.84. What is the ratio of the Value added (in %) of Hungary in 1976 to that in 1980?
Ensure brevity in your answer.  1.1. What is the ratio of the Value added (in %) in Nicaragua in 1976 to that in 1980?
Give a very brief answer. 2.09. What is the ratio of the Value added (in %) of Austria in 1976 to that in 1981?
Provide a succinct answer. 0.81. What is the ratio of the Value added (in %) in Burkina Faso in 1976 to that in 1981?
Provide a short and direct response. 0.85. What is the ratio of the Value added (in %) in Hungary in 1976 to that in 1981?
Make the answer very short. 1.06. What is the ratio of the Value added (in %) in Nicaragua in 1976 to that in 1981?
Offer a very short reply. 1.05. What is the ratio of the Value added (in %) of Austria in 1976 to that in 1982?
Provide a succinct answer. 0.81. What is the ratio of the Value added (in %) in Burkina Faso in 1976 to that in 1982?
Ensure brevity in your answer.  1.2. What is the ratio of the Value added (in %) in Hungary in 1976 to that in 1982?
Keep it short and to the point. 0.96. What is the ratio of the Value added (in %) of Nicaragua in 1976 to that in 1982?
Offer a very short reply. 1.19. What is the ratio of the Value added (in %) of Austria in 1976 to that in 1983?
Offer a terse response. 0.92. What is the ratio of the Value added (in %) of Burkina Faso in 1976 to that in 1983?
Provide a succinct answer. 1.55. What is the ratio of the Value added (in %) of Hungary in 1976 to that in 1983?
Make the answer very short. 0.94. What is the ratio of the Value added (in %) of Nicaragua in 1976 to that in 1983?
Provide a short and direct response. 1.36. What is the ratio of the Value added (in %) in Austria in 1977 to that in 1978?
Keep it short and to the point. 0.99. What is the ratio of the Value added (in %) in Burkina Faso in 1977 to that in 1978?
Your answer should be compact. 0.99. What is the ratio of the Value added (in %) in Hungary in 1977 to that in 1978?
Offer a terse response. 1.03. What is the ratio of the Value added (in %) in Nicaragua in 1977 to that in 1978?
Provide a succinct answer. 0.97. What is the ratio of the Value added (in %) in Austria in 1977 to that in 1979?
Your answer should be very brief. 1. What is the ratio of the Value added (in %) of Burkina Faso in 1977 to that in 1979?
Provide a short and direct response. 0.93. What is the ratio of the Value added (in %) of Hungary in 1977 to that in 1979?
Offer a terse response. 1.06. What is the ratio of the Value added (in %) in Nicaragua in 1977 to that in 1979?
Offer a terse response. 1.42. What is the ratio of the Value added (in %) of Austria in 1977 to that in 1980?
Your answer should be compact. 0.84. What is the ratio of the Value added (in %) in Burkina Faso in 1977 to that in 1980?
Give a very brief answer. 0.84. What is the ratio of the Value added (in %) in Hungary in 1977 to that in 1980?
Give a very brief answer. 1.18. What is the ratio of the Value added (in %) of Nicaragua in 1977 to that in 1980?
Ensure brevity in your answer.  2.12. What is the ratio of the Value added (in %) of Austria in 1977 to that in 1981?
Ensure brevity in your answer.  0.81. What is the ratio of the Value added (in %) in Burkina Faso in 1977 to that in 1981?
Give a very brief answer. 0.85. What is the ratio of the Value added (in %) in Hungary in 1977 to that in 1981?
Offer a very short reply. 1.13. What is the ratio of the Value added (in %) of Nicaragua in 1977 to that in 1981?
Give a very brief answer. 1.06. What is the ratio of the Value added (in %) of Austria in 1977 to that in 1982?
Offer a very short reply. 0.8. What is the ratio of the Value added (in %) of Burkina Faso in 1977 to that in 1982?
Ensure brevity in your answer.  1.2. What is the ratio of the Value added (in %) in Hungary in 1977 to that in 1982?
Offer a terse response. 1.02. What is the ratio of the Value added (in %) in Nicaragua in 1977 to that in 1982?
Your response must be concise. 1.2. What is the ratio of the Value added (in %) in Austria in 1977 to that in 1983?
Your answer should be compact. 0.92. What is the ratio of the Value added (in %) of Burkina Faso in 1977 to that in 1983?
Your response must be concise. 1.56. What is the ratio of the Value added (in %) of Hungary in 1977 to that in 1983?
Provide a succinct answer. 1.01. What is the ratio of the Value added (in %) of Nicaragua in 1977 to that in 1983?
Offer a terse response. 1.38. What is the ratio of the Value added (in %) in Austria in 1978 to that in 1979?
Offer a terse response. 1.01. What is the ratio of the Value added (in %) of Burkina Faso in 1978 to that in 1979?
Offer a very short reply. 0.94. What is the ratio of the Value added (in %) of Hungary in 1978 to that in 1979?
Make the answer very short. 1.03. What is the ratio of the Value added (in %) of Nicaragua in 1978 to that in 1979?
Ensure brevity in your answer.  1.46. What is the ratio of the Value added (in %) of Austria in 1978 to that in 1980?
Offer a very short reply. 0.85. What is the ratio of the Value added (in %) of Burkina Faso in 1978 to that in 1980?
Your answer should be compact. 0.85. What is the ratio of the Value added (in %) in Hungary in 1978 to that in 1980?
Offer a terse response. 1.15. What is the ratio of the Value added (in %) of Nicaragua in 1978 to that in 1980?
Make the answer very short. 2.19. What is the ratio of the Value added (in %) of Austria in 1978 to that in 1981?
Provide a succinct answer. 0.82. What is the ratio of the Value added (in %) in Burkina Faso in 1978 to that in 1981?
Give a very brief answer. 0.86. What is the ratio of the Value added (in %) of Hungary in 1978 to that in 1981?
Provide a succinct answer. 1.1. What is the ratio of the Value added (in %) of Nicaragua in 1978 to that in 1981?
Provide a succinct answer. 1.1. What is the ratio of the Value added (in %) of Austria in 1978 to that in 1982?
Offer a terse response. 0.81. What is the ratio of the Value added (in %) in Burkina Faso in 1978 to that in 1982?
Provide a succinct answer. 1.21. What is the ratio of the Value added (in %) in Hungary in 1978 to that in 1982?
Keep it short and to the point. 1. What is the ratio of the Value added (in %) in Nicaragua in 1978 to that in 1982?
Make the answer very short. 1.24. What is the ratio of the Value added (in %) of Austria in 1978 to that in 1983?
Provide a short and direct response. 0.93. What is the ratio of the Value added (in %) of Burkina Faso in 1978 to that in 1983?
Offer a very short reply. 1.57. What is the ratio of the Value added (in %) in Hungary in 1978 to that in 1983?
Make the answer very short. 0.98. What is the ratio of the Value added (in %) in Nicaragua in 1978 to that in 1983?
Make the answer very short. 1.43. What is the ratio of the Value added (in %) in Austria in 1979 to that in 1980?
Ensure brevity in your answer.  0.84. What is the ratio of the Value added (in %) of Burkina Faso in 1979 to that in 1980?
Provide a short and direct response. 0.91. What is the ratio of the Value added (in %) of Hungary in 1979 to that in 1980?
Offer a terse response. 1.11. What is the ratio of the Value added (in %) of Nicaragua in 1979 to that in 1980?
Offer a very short reply. 1.5. What is the ratio of the Value added (in %) of Austria in 1979 to that in 1981?
Your answer should be very brief. 0.81. What is the ratio of the Value added (in %) of Burkina Faso in 1979 to that in 1981?
Your answer should be compact. 0.92. What is the ratio of the Value added (in %) of Hungary in 1979 to that in 1981?
Keep it short and to the point. 1.07. What is the ratio of the Value added (in %) of Nicaragua in 1979 to that in 1981?
Your answer should be very brief. 0.75. What is the ratio of the Value added (in %) of Austria in 1979 to that in 1982?
Provide a short and direct response. 0.8. What is the ratio of the Value added (in %) in Burkina Faso in 1979 to that in 1982?
Make the answer very short. 1.29. What is the ratio of the Value added (in %) of Hungary in 1979 to that in 1982?
Your answer should be compact. 0.96. What is the ratio of the Value added (in %) of Nicaragua in 1979 to that in 1982?
Offer a terse response. 0.85. What is the ratio of the Value added (in %) in Austria in 1979 to that in 1983?
Offer a terse response. 0.92. What is the ratio of the Value added (in %) in Burkina Faso in 1979 to that in 1983?
Offer a terse response. 1.68. What is the ratio of the Value added (in %) of Hungary in 1979 to that in 1983?
Your response must be concise. 0.95. What is the ratio of the Value added (in %) in Nicaragua in 1979 to that in 1983?
Your answer should be very brief. 0.98. What is the ratio of the Value added (in %) in Austria in 1980 to that in 1981?
Offer a terse response. 0.96. What is the ratio of the Value added (in %) in Burkina Faso in 1980 to that in 1981?
Your response must be concise. 1.01. What is the ratio of the Value added (in %) of Hungary in 1980 to that in 1981?
Give a very brief answer. 0.96. What is the ratio of the Value added (in %) in Nicaragua in 1980 to that in 1981?
Make the answer very short. 0.5. What is the ratio of the Value added (in %) in Austria in 1980 to that in 1982?
Your answer should be very brief. 0.95. What is the ratio of the Value added (in %) of Burkina Faso in 1980 to that in 1982?
Offer a very short reply. 1.42. What is the ratio of the Value added (in %) of Hungary in 1980 to that in 1982?
Provide a succinct answer. 0.87. What is the ratio of the Value added (in %) of Nicaragua in 1980 to that in 1982?
Offer a terse response. 0.57. What is the ratio of the Value added (in %) of Austria in 1980 to that in 1983?
Offer a terse response. 1.09. What is the ratio of the Value added (in %) of Burkina Faso in 1980 to that in 1983?
Give a very brief answer. 1.84. What is the ratio of the Value added (in %) of Hungary in 1980 to that in 1983?
Make the answer very short. 0.85. What is the ratio of the Value added (in %) in Nicaragua in 1980 to that in 1983?
Your answer should be very brief. 0.65. What is the ratio of the Value added (in %) of Burkina Faso in 1981 to that in 1982?
Make the answer very short. 1.41. What is the ratio of the Value added (in %) of Hungary in 1981 to that in 1982?
Your answer should be very brief. 0.9. What is the ratio of the Value added (in %) of Nicaragua in 1981 to that in 1982?
Provide a short and direct response. 1.13. What is the ratio of the Value added (in %) in Austria in 1981 to that in 1983?
Keep it short and to the point. 1.14. What is the ratio of the Value added (in %) of Burkina Faso in 1981 to that in 1983?
Make the answer very short. 1.83. What is the ratio of the Value added (in %) of Hungary in 1981 to that in 1983?
Offer a terse response. 0.89. What is the ratio of the Value added (in %) in Nicaragua in 1981 to that in 1983?
Give a very brief answer. 1.3. What is the ratio of the Value added (in %) in Austria in 1982 to that in 1983?
Provide a short and direct response. 1.14. What is the ratio of the Value added (in %) of Burkina Faso in 1982 to that in 1983?
Your answer should be very brief. 1.3. What is the ratio of the Value added (in %) of Hungary in 1982 to that in 1983?
Your response must be concise. 0.99. What is the ratio of the Value added (in %) in Nicaragua in 1982 to that in 1983?
Your answer should be very brief. 1.15. What is the difference between the highest and the second highest Value added (in %) of Austria?
Offer a very short reply. 0.09. What is the difference between the highest and the second highest Value added (in %) in Burkina Faso?
Make the answer very short. 0.02. What is the difference between the highest and the second highest Value added (in %) in Hungary?
Make the answer very short. 0.19. What is the difference between the highest and the second highest Value added (in %) in Nicaragua?
Your answer should be compact. 0.02. What is the difference between the highest and the lowest Value added (in %) in Austria?
Your answer should be very brief. 3.05. What is the difference between the highest and the lowest Value added (in %) in Burkina Faso?
Your answer should be compact. 1. What is the difference between the highest and the lowest Value added (in %) of Hungary?
Offer a very short reply. 3.01. What is the difference between the highest and the lowest Value added (in %) in Nicaragua?
Ensure brevity in your answer.  0.44. 